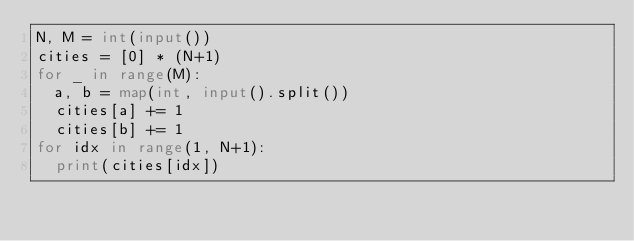<code> <loc_0><loc_0><loc_500><loc_500><_Python_>N, M = int(input())
cities = [0] * (N+1)
for _ in range(M):
  a, b = map(int, input().split())
  cities[a] += 1
  cities[b] += 1
for idx in range(1, N+1):
  print(cities[idx])</code> 